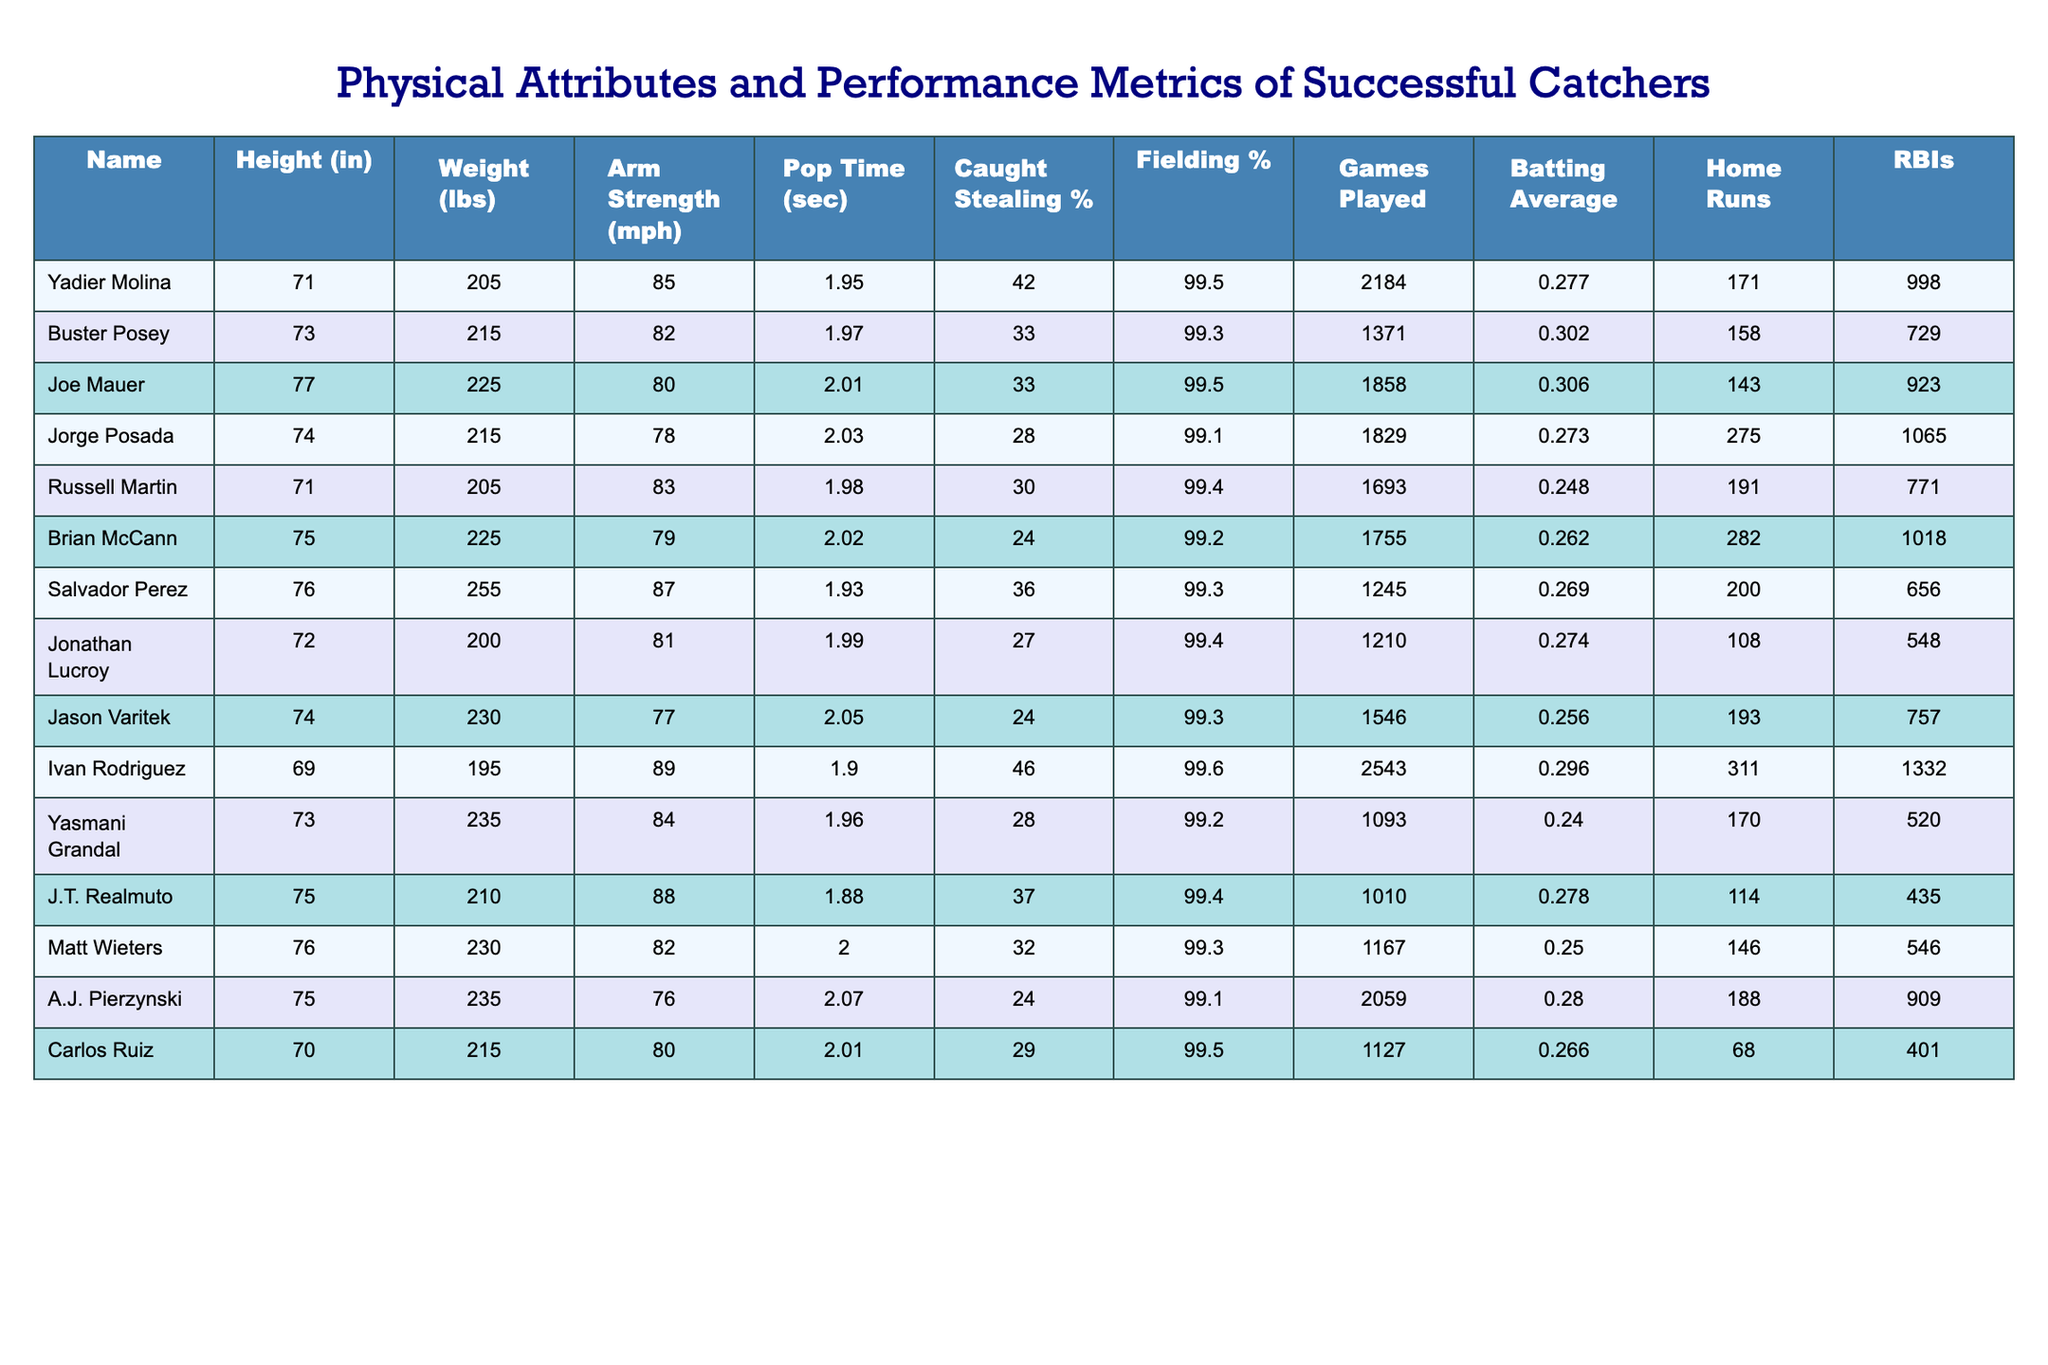What is the height of Yadier Molina? According to the table, Yadier Molina's height is listed as 71 inches.
Answer: 71 inches Which catcher has the highest caught stealing percentage? The table shows that Ivan Rodriguez has the highest caught stealing percentage at 46%.
Answer: 46% What is the average weight of the catchers listed? To calculate the average weight, add all the weights: (205 + 215 + 225 + 215 + 205 + 225 + 255 + 200 + 230 + 195 + 235 + 210 + 230 + 235 + 215) = 3415 lbs. There are 15 catchers, so 3415 / 15 = 227.67 lbs (approximately).
Answer: 227.67 lbs Did any catcher achieve a batting average over .300? Yes, both Joe Mauer and Buster Posey have batting averages over .300, with Joe Mauer at .306 and Buster Posey at .302.
Answer: Yes Who has the most home runs among the catchers? The table indicates that Jorge Posada has the most home runs, totaling 275.
Answer: 275 What is the difference in arm strength between Ivan Rodriguez and A.J. Pierzynski? Ivan Rodriguez has an arm strength of 89 mph and A.J. Pierzynski has 76 mph. The difference is 89 - 76 = 13 mph.
Answer: 13 mph Which catcher played the most games? The table reveals that Ivan Rodriguez played the most games, totaling 2543 games.
Answer: 2543 games What percentage of successful catchers have a fielding percentage of 99.5% or higher? From the table, 5 out of 15 catchers have a fielding percentage of 99.5% or higher. To find the percentage, calculate (5/15) * 100 = 33.33%.
Answer: 33.33% Who has the lowest batting average among the catchers listed? According to the table, Russell Martin has the lowest batting average at .248.
Answer: .248 What is the average pop time of the catchers? To find the average pop time, sum the pop times: (1.95 + 1.97 + 2.01 + 2.03 + 1.98 + 2.02 + 1.93 + 1.99 + 2.05 + 1.90 + 1.96 + 1.88 + 2.00 + 2.07 + 2.01) = 29.38 seconds. Divide by 15 catchers gives 29.38 / 15 = 1.958 seconds (approximately).
Answer: 1.958 seconds How many catchers have a weight of 225 lbs or more? Looking at the table, there are 4 catchers with a weight of 225 lbs or more: Joe Mauer, Brian McCann, Salvador Perez, and A.J. Pierzynski.
Answer: 4 catchers 